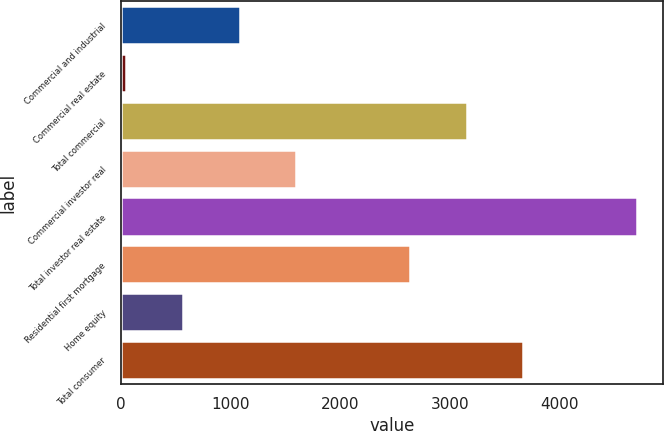Convert chart. <chart><loc_0><loc_0><loc_500><loc_500><bar_chart><fcel>Commercial and industrial<fcel>Commercial real estate<fcel>Total commercial<fcel>Commercial investor real<fcel>Total investor real estate<fcel>Residential first mortgage<fcel>Home equity<fcel>Total consumer<nl><fcel>1083<fcel>47<fcel>3155<fcel>1601<fcel>4709<fcel>2637<fcel>565<fcel>3673<nl></chart> 